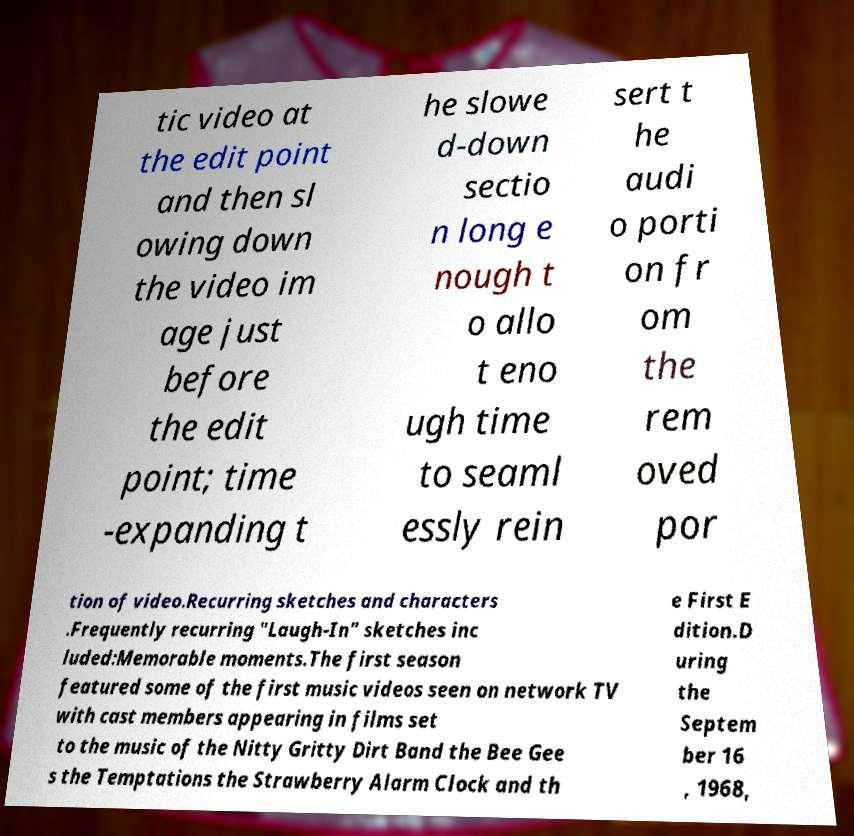Can you read and provide the text displayed in the image?This photo seems to have some interesting text. Can you extract and type it out for me? tic video at the edit point and then sl owing down the video im age just before the edit point; time -expanding t he slowe d-down sectio n long e nough t o allo t eno ugh time to seaml essly rein sert t he audi o porti on fr om the rem oved por tion of video.Recurring sketches and characters .Frequently recurring "Laugh-In" sketches inc luded:Memorable moments.The first season featured some of the first music videos seen on network TV with cast members appearing in films set to the music of the Nitty Gritty Dirt Band the Bee Gee s the Temptations the Strawberry Alarm Clock and th e First E dition.D uring the Septem ber 16 , 1968, 